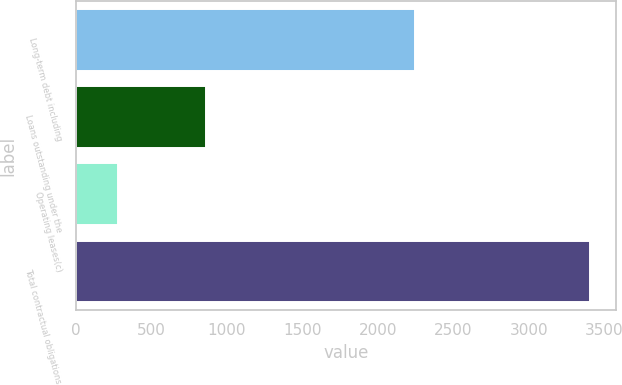<chart> <loc_0><loc_0><loc_500><loc_500><bar_chart><fcel>Long-term debt including<fcel>Loans outstanding under the<fcel>Operating leases(c)<fcel>Total contractual obligations<nl><fcel>2248<fcel>860<fcel>280<fcel>3407<nl></chart> 